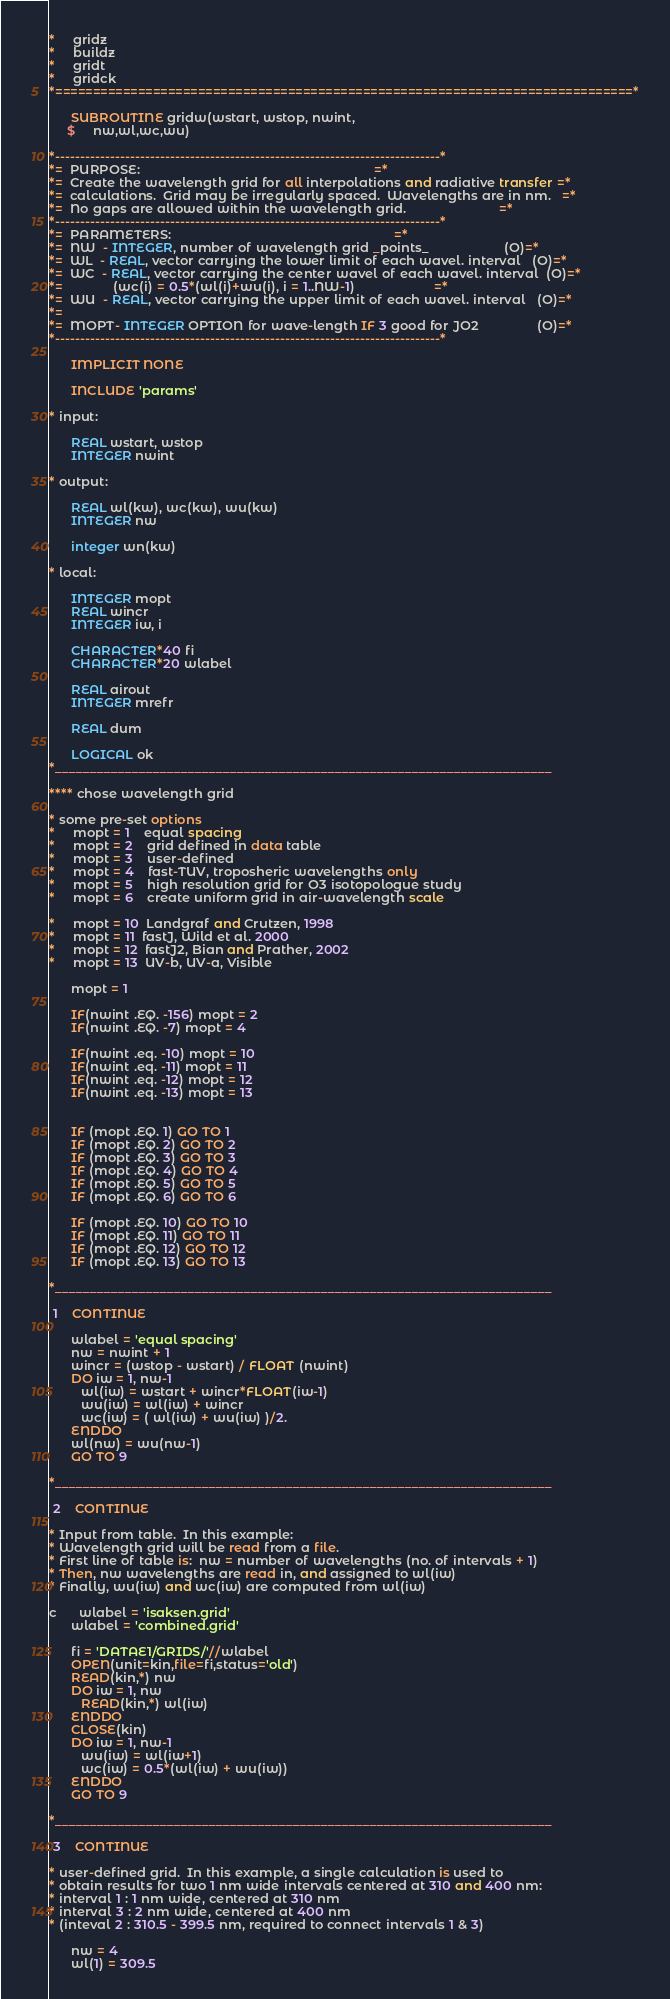<code> <loc_0><loc_0><loc_500><loc_500><_FORTRAN_>*     gridz
*     buildz
*     gridt
*     gridck
*=============================================================================*

      SUBROUTINE gridw(wstart, wstop, nwint,
     $     nw,wl,wc,wu)

*-----------------------------------------------------------------------------*
*=  PURPOSE:                                                                 =*
*=  Create the wavelength grid for all interpolations and radiative transfer =*
*=  calculations.  Grid may be irregularly spaced.  Wavelengths are in nm.   =*
*=  No gaps are allowed within the wavelength grid.                          =*
*-----------------------------------------------------------------------------*
*=  PARAMETERS:                                                              =*
*=  NW  - INTEGER, number of wavelength grid _points_                     (O)=*
*=  WL  - REAL, vector carrying the lower limit of each wavel. interval   (O)=*
*=  WC  - REAL, vector carrying the center wavel of each wavel. interval  (O)=*
*=              (wc(i) = 0.5*(wl(i)+wu(i), i = 1..NW-1)                      =*
*=  WU  - REAL, vector carrying the upper limit of each wavel. interval   (O)=*
*=
*=  MOPT- INTEGER OPTION for wave-length IF 3 good for JO2                (O)=*
*-----------------------------------------------------------------------------*

      IMPLICIT NONE

      INCLUDE 'params'

* input:

      REAL wstart, wstop
      INTEGER nwint

* output:

      REAL wl(kw), wc(kw), wu(kw)
      INTEGER nw

      integer wn(kw)

* local:

      INTEGER mopt
      REAL wincr
      INTEGER iw, i

      CHARACTER*40 fi
      CHARACTER*20 wlabel

      REAL airout
      INTEGER mrefr

      REAL dum

      LOGICAL ok
*_______________________________________________________________________

**** chose wavelength grid

* some pre-set options
*     mopt = 1    equal spacing
*     mopt = 2    grid defined in data table
*     mopt = 3    user-defined
*     mopt = 4    fast-TUV, troposheric wavelengths only
*     mopt = 5    high resolution grid for O3 isotopologue study
*     mopt = 6    create uniform grid in air-wavelength scale

*     mopt = 10  Landgraf and Crutzen, 1998
*     mopt = 11  fastJ, Wild et al. 2000
*     mopt = 12  fastJ2, Bian and Prather, 2002
*     mopt = 13  UV-b, UV-a, Visible

      mopt = 1

      IF(nwint .EQ. -156) mopt = 2
      IF(nwint .EQ. -7) mopt = 4

      IF(nwint .eq. -10) mopt = 10
      IF(nwint .eq. -11) mopt = 11
      IF(nwint .eq. -12) mopt = 12
      IF(nwint .eq. -13) mopt = 13


      IF (mopt .EQ. 1) GO TO 1
      IF (mopt .EQ. 2) GO TO 2
      IF (mopt .EQ. 3) GO TO 3
      IF (mopt .EQ. 4) GO TO 4
      IF (mopt .EQ. 5) GO TO 5
      IF (mopt .EQ. 6) GO TO 6

      IF (mopt .EQ. 10) GO TO 10
      IF (mopt .EQ. 11) GO TO 11
      IF (mopt .EQ. 12) GO TO 12
      IF (mopt .EQ. 13) GO TO 13

*_______________________________________________________________________

 1    CONTINUE

      wlabel = 'equal spacing'
      nw = nwint + 1
      wincr = (wstop - wstart) / FLOAT (nwint)
      DO iw = 1, nw-1
         wl(iw) = wstart + wincr*FLOAT(iw-1)
         wu(iw) = wl(iw) + wincr
         wc(iw) = ( wl(iw) + wu(iw) )/2.
      ENDDO
      wl(nw) = wu(nw-1)
      GO TO 9

*_______________________________________________________________________

 2    CONTINUE

* Input from table.  In this example:
* Wavelength grid will be read from a file.
* First line of table is:  nw = number of wavelengths (no. of intervals + 1)
* Then, nw wavelengths are read in, and assigned to wl(iw)
* Finally, wu(iw) and wc(iw) are computed from wl(iw)

c      wlabel = 'isaksen.grid'
      wlabel = 'combined.grid'

      fi = 'DATAE1/GRIDS/'//wlabel
      OPEN(unit=kin,file=fi,status='old')
      READ(kin,*) nw
      DO iw = 1, nw
         READ(kin,*) wl(iw)
      ENDDO
      CLOSE(kin)
      DO iw = 1, nw-1
         wu(iw) = wl(iw+1)
         wc(iw) = 0.5*(wl(iw) + wu(iw))
      ENDDO
      GO TO 9

*_______________________________________________________________________

 3    CONTINUE

* user-defined grid.  In this example, a single calculation is used to 
* obtain results for two 1 nm wide intervals centered at 310 and 400 nm:
* interval 1 : 1 nm wide, centered at 310 nm
* interval 3 : 2 nm wide, centered at 400 nm
* (inteval 2 : 310.5 - 399.5 nm, required to connect intervals 1 & 3)

      nw = 4
      wl(1) = 309.5</code> 